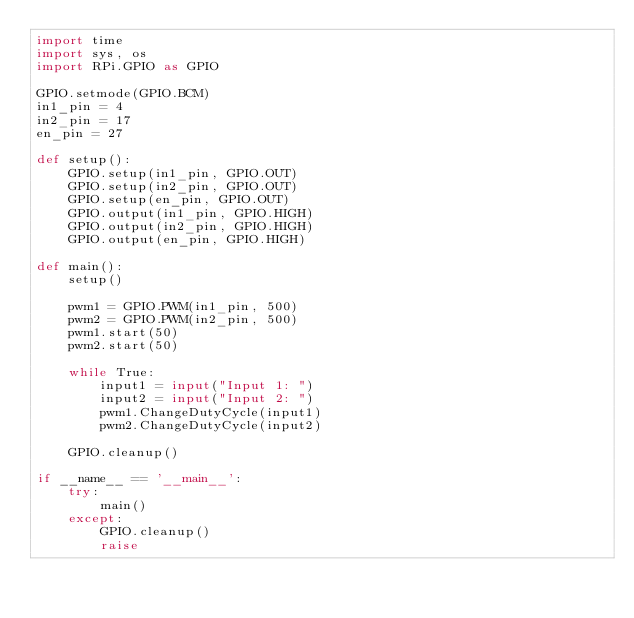<code> <loc_0><loc_0><loc_500><loc_500><_Python_>import time
import sys, os
import RPi.GPIO as GPIO

GPIO.setmode(GPIO.BCM)
in1_pin = 4
in2_pin = 17
en_pin = 27

def setup():
    GPIO.setup(in1_pin, GPIO.OUT)
    GPIO.setup(in2_pin, GPIO.OUT)
    GPIO.setup(en_pin, GPIO.OUT)
    GPIO.output(in1_pin, GPIO.HIGH)
    GPIO.output(in2_pin, GPIO.HIGH)
    GPIO.output(en_pin, GPIO.HIGH)
        
def main():
    setup()

    pwm1 = GPIO.PWM(in1_pin, 500)
    pwm2 = GPIO.PWM(in2_pin, 500)
    pwm1.start(50)
    pwm2.start(50)

    while True:
        input1 = input("Input 1: ")
        input2 = input("Input 2: ")
        pwm1.ChangeDutyCycle(input1)
        pwm2.ChangeDutyCycle(input2)
        
    GPIO.cleanup()

if __name__ == '__main__':
    try:
        main()
    except:
        GPIO.cleanup()
        raise</code> 